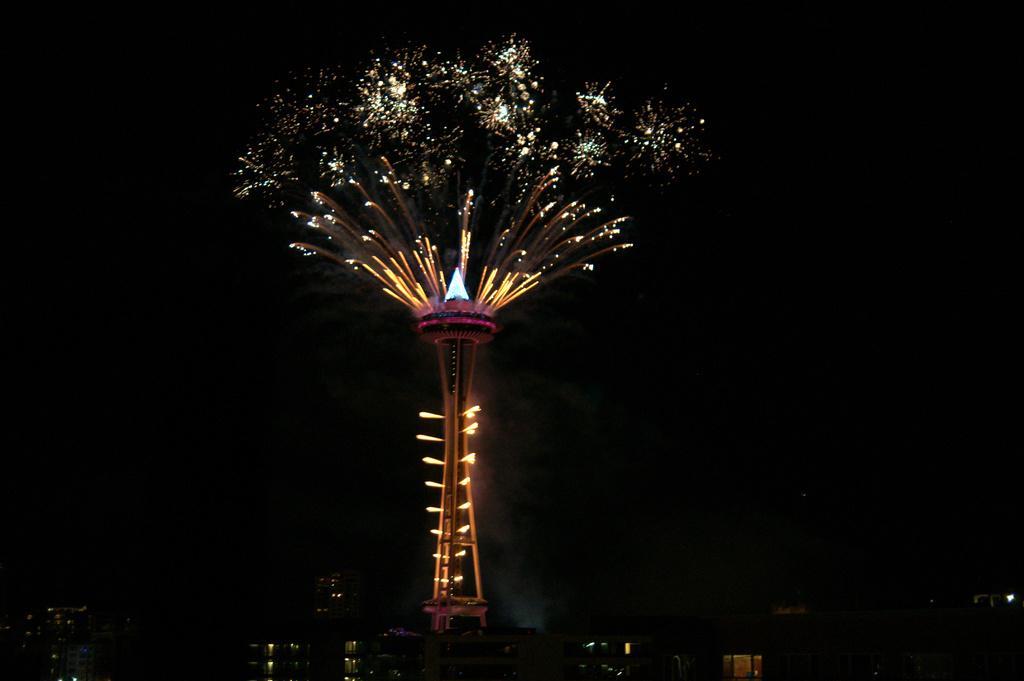Can you describe this image briefly? In this picture I can see a tower with lights in the middle, at the top there is the sky. 